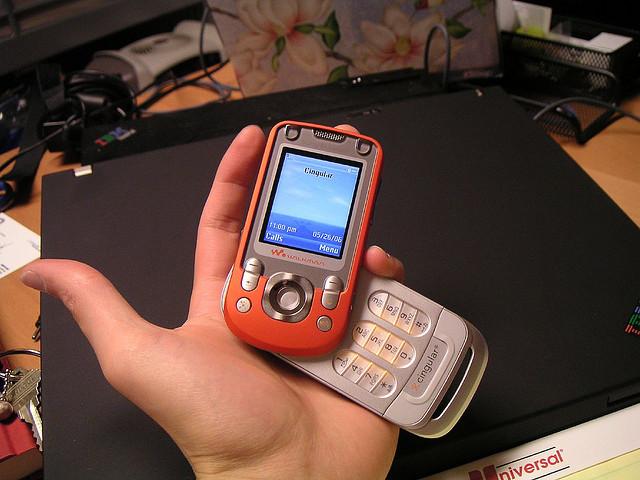How many buttons are on the phone?
Keep it brief. 7. What is the person holding the phone doing?
Write a very short answer. Texting. What kind of device is the person holding in his hand?
Short answer required. Cell phone. How old do you think these phones are?
Answer briefly. 10 years. What color is the phone?
Short answer required. Orange. What color is the phone case?
Short answer required. Orange. Is that a flip phone?
Quick response, please. Yes. What finger is completely hidden by the cell phone?
Concise answer only. Middle. What brand of laptop is in the photo?
Write a very short answer. Ibm. 